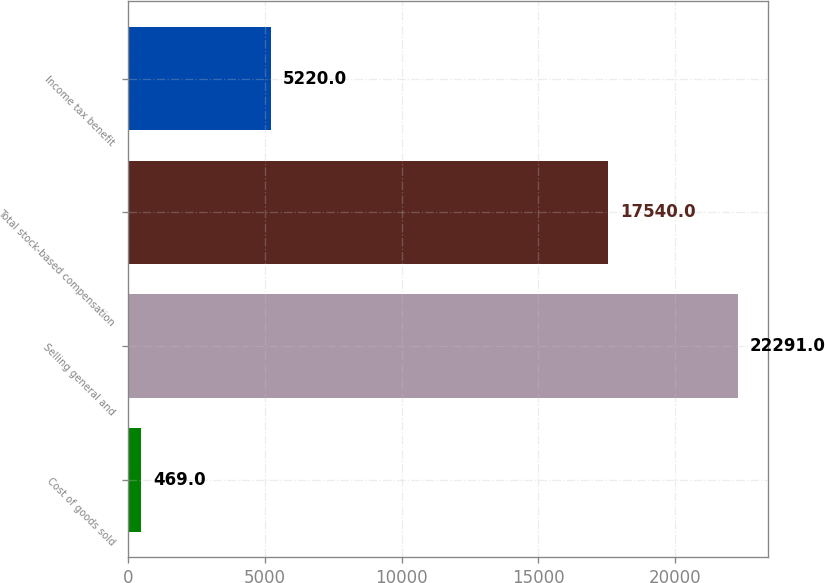Convert chart. <chart><loc_0><loc_0><loc_500><loc_500><bar_chart><fcel>Cost of goods sold<fcel>Selling general and<fcel>Total stock-based compensation<fcel>Income tax benefit<nl><fcel>469<fcel>22291<fcel>17540<fcel>5220<nl></chart> 